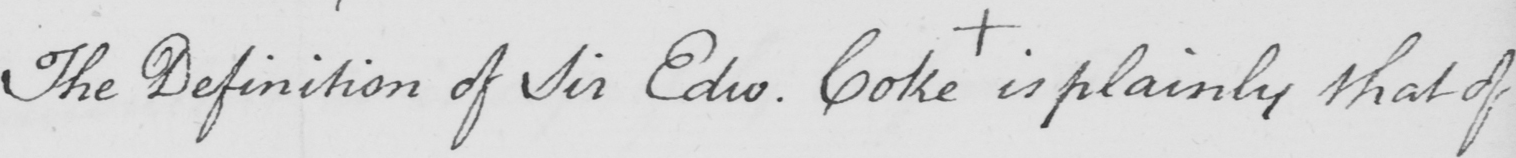Can you read and transcribe this handwriting? The Definition of Sir Edw . Coke  +  is plainly that of 